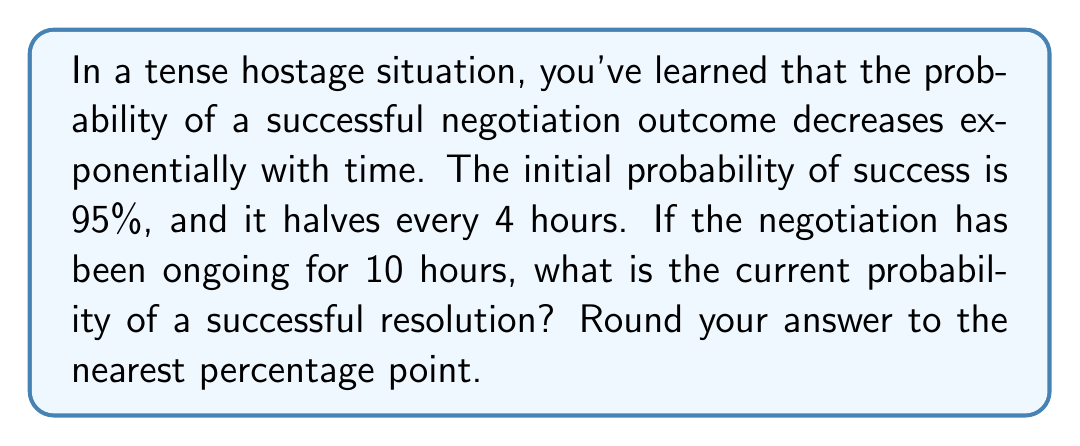Give your solution to this math problem. Let's approach this step-by-step:

1) Let $P(t)$ be the probability of success after $t$ hours.
2) We're given that $P(0) = 0.95$ (95% initial probability).
3) The probability halves every 4 hours, so we can model this as an exponential decay:

   $$P(t) = P(0) \cdot (0.5)^{\frac{t}{4}}$$

4) We need to find $P(10)$, so let's substitute $t=10$:

   $$P(10) = 0.95 \cdot (0.5)^{\frac{10}{4}}$$

5) Simplify the exponent:
   
   $$P(10) = 0.95 \cdot (0.5)^{2.5}$$

6) Calculate $(0.5)^{2.5}$:
   
   $$(0.5)^{2.5} = \sqrt{(0.5)^5} \approx 0.1768$$

7) Multiply:
   
   $$P(10) = 0.95 \cdot 0.1768 \approx 0.16796$$

8) Convert to a percentage and round to the nearest point:
   
   $$0.16796 \cdot 100\% \approx 16.8\% \approx 17\%$$
Answer: 17% 